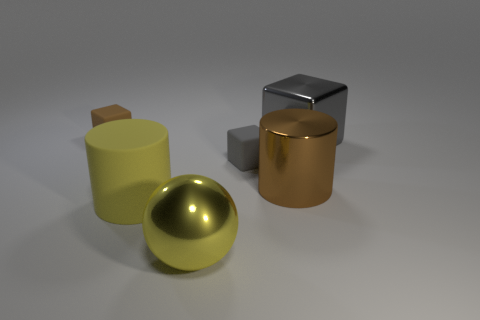Does the yellow rubber thing have the same shape as the large yellow metallic thing?
Your answer should be very brief. No. What number of things are either things on the left side of the yellow metallic thing or small rubber blocks?
Give a very brief answer. 3. There is a tiny matte object that is in front of the rubber cube that is to the left of the gray cube that is in front of the big gray thing; what is its shape?
Your answer should be compact. Cube. The other small object that is made of the same material as the small gray object is what shape?
Your response must be concise. Cube. What size is the yellow cylinder?
Your response must be concise. Large. Does the metallic sphere have the same size as the yellow matte thing?
Keep it short and to the point. Yes. What number of objects are either brown objects that are on the right side of the big ball or gray blocks to the left of the large brown shiny object?
Your answer should be compact. 2. There is a small cube that is in front of the brown object behind the brown metallic object; what number of big cylinders are on the right side of it?
Offer a terse response. 1. How big is the brown object left of the large yellow ball?
Make the answer very short. Small. What number of yellow matte cylinders are the same size as the shiny cube?
Provide a succinct answer. 1. 